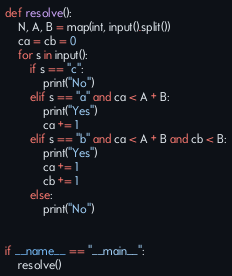Convert code to text. <code><loc_0><loc_0><loc_500><loc_500><_Python_>def resolve():
    N, A, B = map(int, input().split())
    ca = cb = 0
    for s in input():
        if s == "c":
            print("No")
        elif s == "a" and ca < A + B:
            print("Yes")
            ca += 1
        elif s == "b" and ca < A + B and cb < B:
            print("Yes")
            ca += 1
            cb += 1
        else:
            print("No")


if __name__ == "__main__":
    resolve()</code> 